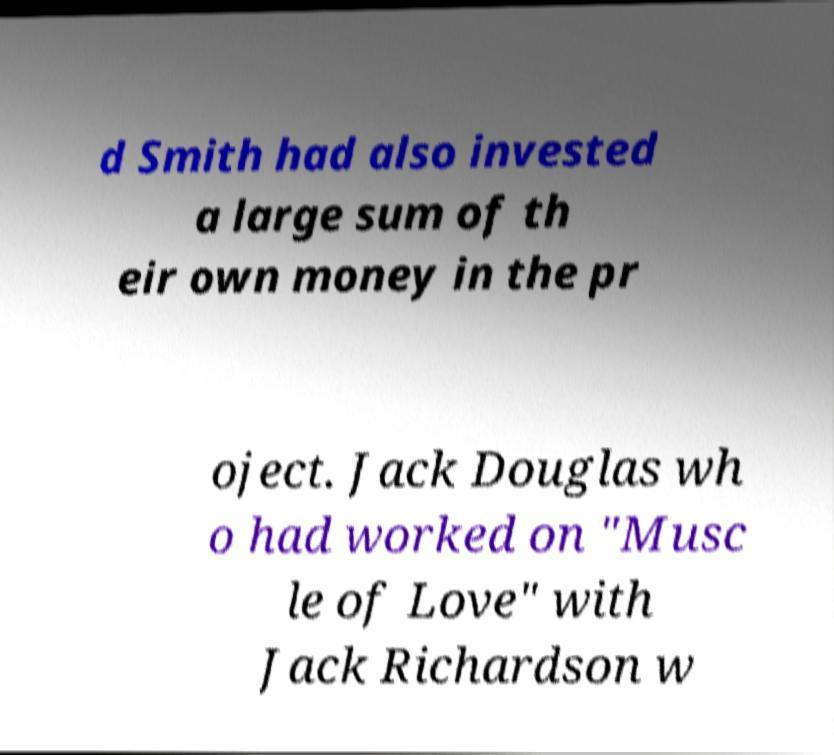For documentation purposes, I need the text within this image transcribed. Could you provide that? d Smith had also invested a large sum of th eir own money in the pr oject. Jack Douglas wh o had worked on "Musc le of Love" with Jack Richardson w 